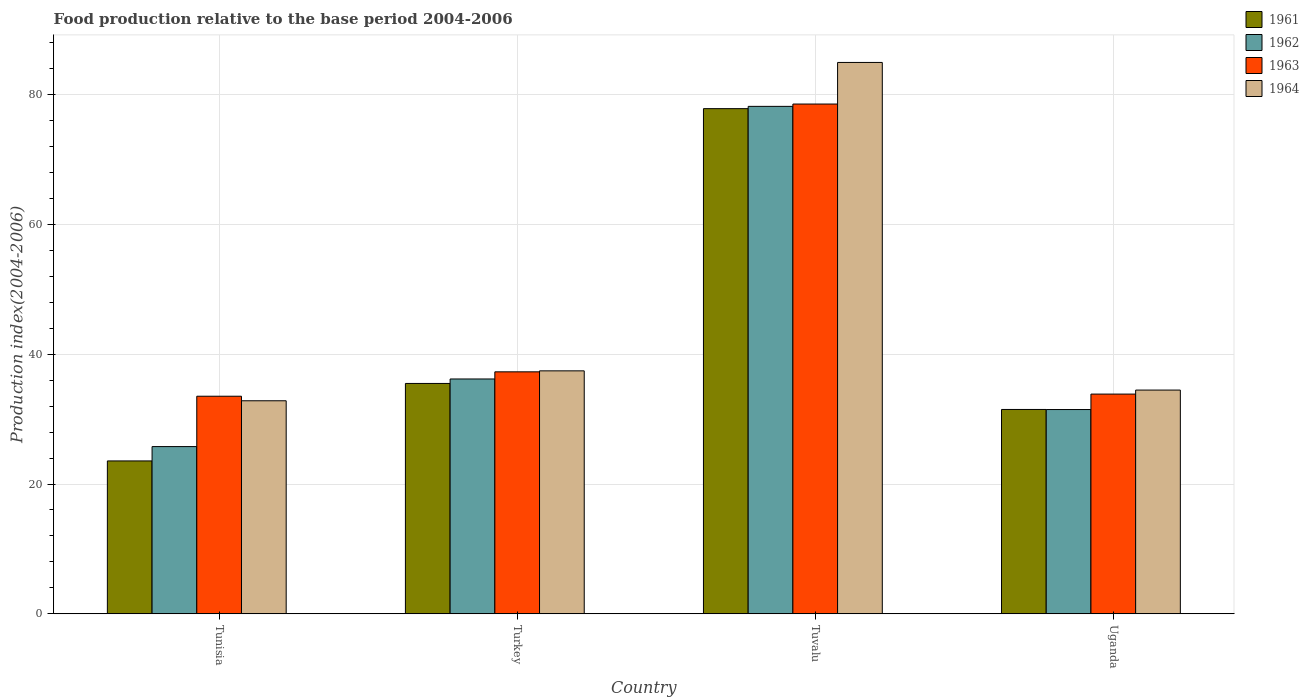How many bars are there on the 3rd tick from the left?
Offer a very short reply. 4. What is the label of the 1st group of bars from the left?
Your answer should be compact. Tunisia. In how many cases, is the number of bars for a given country not equal to the number of legend labels?
Your answer should be very brief. 0. What is the food production index in 1963 in Turkey?
Your response must be concise. 37.29. Across all countries, what is the maximum food production index in 1961?
Provide a short and direct response. 77.85. Across all countries, what is the minimum food production index in 1962?
Your response must be concise. 25.77. In which country was the food production index in 1963 maximum?
Offer a very short reply. Tuvalu. In which country was the food production index in 1964 minimum?
Provide a short and direct response. Tunisia. What is the total food production index in 1964 in the graph?
Your response must be concise. 189.72. What is the difference between the food production index in 1963 in Turkey and that in Uganda?
Offer a terse response. 3.43. What is the difference between the food production index in 1964 in Uganda and the food production index in 1961 in Tunisia?
Your response must be concise. 10.92. What is the average food production index in 1962 per country?
Provide a short and direct response. 42.91. What is the difference between the food production index of/in 1964 and food production index of/in 1962 in Uganda?
Give a very brief answer. 3. What is the ratio of the food production index in 1964 in Turkey to that in Uganda?
Your response must be concise. 1.09. Is the difference between the food production index in 1964 in Tunisia and Tuvalu greater than the difference between the food production index in 1962 in Tunisia and Tuvalu?
Your response must be concise. Yes. What is the difference between the highest and the second highest food production index in 1963?
Your answer should be compact. -3.43. What is the difference between the highest and the lowest food production index in 1963?
Your answer should be compact. 45.03. In how many countries, is the food production index in 1962 greater than the average food production index in 1962 taken over all countries?
Offer a terse response. 1. Is the sum of the food production index in 1962 in Tunisia and Tuvalu greater than the maximum food production index in 1964 across all countries?
Keep it short and to the point. Yes. Is it the case that in every country, the sum of the food production index in 1964 and food production index in 1962 is greater than the sum of food production index in 1961 and food production index in 1963?
Offer a terse response. No. What does the 3rd bar from the left in Tuvalu represents?
Give a very brief answer. 1963. Are the values on the major ticks of Y-axis written in scientific E-notation?
Your response must be concise. No. How many legend labels are there?
Give a very brief answer. 4. What is the title of the graph?
Your response must be concise. Food production relative to the base period 2004-2006. Does "1992" appear as one of the legend labels in the graph?
Provide a succinct answer. No. What is the label or title of the X-axis?
Keep it short and to the point. Country. What is the label or title of the Y-axis?
Give a very brief answer. Production index(2004-2006). What is the Production index(2004-2006) in 1961 in Tunisia?
Your response must be concise. 23.56. What is the Production index(2004-2006) of 1962 in Tunisia?
Your answer should be very brief. 25.77. What is the Production index(2004-2006) in 1963 in Tunisia?
Make the answer very short. 33.53. What is the Production index(2004-2006) in 1964 in Tunisia?
Keep it short and to the point. 32.83. What is the Production index(2004-2006) of 1961 in Turkey?
Give a very brief answer. 35.5. What is the Production index(2004-2006) in 1962 in Turkey?
Offer a very short reply. 36.19. What is the Production index(2004-2006) in 1963 in Turkey?
Your response must be concise. 37.29. What is the Production index(2004-2006) of 1964 in Turkey?
Provide a short and direct response. 37.44. What is the Production index(2004-2006) of 1961 in Tuvalu?
Keep it short and to the point. 77.85. What is the Production index(2004-2006) in 1962 in Tuvalu?
Offer a terse response. 78.2. What is the Production index(2004-2006) of 1963 in Tuvalu?
Your answer should be very brief. 78.56. What is the Production index(2004-2006) in 1964 in Tuvalu?
Make the answer very short. 84.97. What is the Production index(2004-2006) in 1961 in Uganda?
Your answer should be compact. 31.49. What is the Production index(2004-2006) of 1962 in Uganda?
Make the answer very short. 31.48. What is the Production index(2004-2006) of 1963 in Uganda?
Your answer should be compact. 33.86. What is the Production index(2004-2006) of 1964 in Uganda?
Your answer should be very brief. 34.48. Across all countries, what is the maximum Production index(2004-2006) of 1961?
Keep it short and to the point. 77.85. Across all countries, what is the maximum Production index(2004-2006) of 1962?
Provide a short and direct response. 78.2. Across all countries, what is the maximum Production index(2004-2006) in 1963?
Make the answer very short. 78.56. Across all countries, what is the maximum Production index(2004-2006) in 1964?
Keep it short and to the point. 84.97. Across all countries, what is the minimum Production index(2004-2006) in 1961?
Your answer should be compact. 23.56. Across all countries, what is the minimum Production index(2004-2006) in 1962?
Your answer should be compact. 25.77. Across all countries, what is the minimum Production index(2004-2006) of 1963?
Your response must be concise. 33.53. Across all countries, what is the minimum Production index(2004-2006) in 1964?
Your answer should be compact. 32.83. What is the total Production index(2004-2006) of 1961 in the graph?
Give a very brief answer. 168.4. What is the total Production index(2004-2006) of 1962 in the graph?
Offer a very short reply. 171.64. What is the total Production index(2004-2006) in 1963 in the graph?
Provide a short and direct response. 183.24. What is the total Production index(2004-2006) of 1964 in the graph?
Make the answer very short. 189.72. What is the difference between the Production index(2004-2006) in 1961 in Tunisia and that in Turkey?
Provide a short and direct response. -11.94. What is the difference between the Production index(2004-2006) in 1962 in Tunisia and that in Turkey?
Provide a short and direct response. -10.42. What is the difference between the Production index(2004-2006) in 1963 in Tunisia and that in Turkey?
Provide a succinct answer. -3.76. What is the difference between the Production index(2004-2006) in 1964 in Tunisia and that in Turkey?
Provide a short and direct response. -4.61. What is the difference between the Production index(2004-2006) of 1961 in Tunisia and that in Tuvalu?
Provide a succinct answer. -54.29. What is the difference between the Production index(2004-2006) of 1962 in Tunisia and that in Tuvalu?
Provide a succinct answer. -52.43. What is the difference between the Production index(2004-2006) of 1963 in Tunisia and that in Tuvalu?
Provide a short and direct response. -45.03. What is the difference between the Production index(2004-2006) of 1964 in Tunisia and that in Tuvalu?
Make the answer very short. -52.14. What is the difference between the Production index(2004-2006) in 1961 in Tunisia and that in Uganda?
Your answer should be compact. -7.93. What is the difference between the Production index(2004-2006) in 1962 in Tunisia and that in Uganda?
Your answer should be compact. -5.71. What is the difference between the Production index(2004-2006) in 1963 in Tunisia and that in Uganda?
Offer a terse response. -0.33. What is the difference between the Production index(2004-2006) of 1964 in Tunisia and that in Uganda?
Provide a short and direct response. -1.65. What is the difference between the Production index(2004-2006) of 1961 in Turkey and that in Tuvalu?
Your response must be concise. -42.35. What is the difference between the Production index(2004-2006) of 1962 in Turkey and that in Tuvalu?
Offer a very short reply. -42.01. What is the difference between the Production index(2004-2006) in 1963 in Turkey and that in Tuvalu?
Ensure brevity in your answer.  -41.27. What is the difference between the Production index(2004-2006) of 1964 in Turkey and that in Tuvalu?
Keep it short and to the point. -47.53. What is the difference between the Production index(2004-2006) in 1961 in Turkey and that in Uganda?
Ensure brevity in your answer.  4.01. What is the difference between the Production index(2004-2006) in 1962 in Turkey and that in Uganda?
Offer a terse response. 4.71. What is the difference between the Production index(2004-2006) of 1963 in Turkey and that in Uganda?
Provide a short and direct response. 3.43. What is the difference between the Production index(2004-2006) of 1964 in Turkey and that in Uganda?
Provide a succinct answer. 2.96. What is the difference between the Production index(2004-2006) in 1961 in Tuvalu and that in Uganda?
Your response must be concise. 46.36. What is the difference between the Production index(2004-2006) in 1962 in Tuvalu and that in Uganda?
Your answer should be compact. 46.72. What is the difference between the Production index(2004-2006) of 1963 in Tuvalu and that in Uganda?
Provide a short and direct response. 44.7. What is the difference between the Production index(2004-2006) in 1964 in Tuvalu and that in Uganda?
Make the answer very short. 50.49. What is the difference between the Production index(2004-2006) in 1961 in Tunisia and the Production index(2004-2006) in 1962 in Turkey?
Give a very brief answer. -12.63. What is the difference between the Production index(2004-2006) in 1961 in Tunisia and the Production index(2004-2006) in 1963 in Turkey?
Keep it short and to the point. -13.73. What is the difference between the Production index(2004-2006) of 1961 in Tunisia and the Production index(2004-2006) of 1964 in Turkey?
Your answer should be compact. -13.88. What is the difference between the Production index(2004-2006) in 1962 in Tunisia and the Production index(2004-2006) in 1963 in Turkey?
Your response must be concise. -11.52. What is the difference between the Production index(2004-2006) in 1962 in Tunisia and the Production index(2004-2006) in 1964 in Turkey?
Your answer should be compact. -11.67. What is the difference between the Production index(2004-2006) in 1963 in Tunisia and the Production index(2004-2006) in 1964 in Turkey?
Your answer should be compact. -3.91. What is the difference between the Production index(2004-2006) in 1961 in Tunisia and the Production index(2004-2006) in 1962 in Tuvalu?
Provide a short and direct response. -54.64. What is the difference between the Production index(2004-2006) in 1961 in Tunisia and the Production index(2004-2006) in 1963 in Tuvalu?
Your answer should be compact. -55. What is the difference between the Production index(2004-2006) in 1961 in Tunisia and the Production index(2004-2006) in 1964 in Tuvalu?
Make the answer very short. -61.41. What is the difference between the Production index(2004-2006) of 1962 in Tunisia and the Production index(2004-2006) of 1963 in Tuvalu?
Provide a short and direct response. -52.79. What is the difference between the Production index(2004-2006) of 1962 in Tunisia and the Production index(2004-2006) of 1964 in Tuvalu?
Ensure brevity in your answer.  -59.2. What is the difference between the Production index(2004-2006) of 1963 in Tunisia and the Production index(2004-2006) of 1964 in Tuvalu?
Your answer should be very brief. -51.44. What is the difference between the Production index(2004-2006) in 1961 in Tunisia and the Production index(2004-2006) in 1962 in Uganda?
Provide a short and direct response. -7.92. What is the difference between the Production index(2004-2006) of 1961 in Tunisia and the Production index(2004-2006) of 1964 in Uganda?
Provide a short and direct response. -10.92. What is the difference between the Production index(2004-2006) in 1962 in Tunisia and the Production index(2004-2006) in 1963 in Uganda?
Offer a terse response. -8.09. What is the difference between the Production index(2004-2006) in 1962 in Tunisia and the Production index(2004-2006) in 1964 in Uganda?
Give a very brief answer. -8.71. What is the difference between the Production index(2004-2006) in 1963 in Tunisia and the Production index(2004-2006) in 1964 in Uganda?
Your response must be concise. -0.95. What is the difference between the Production index(2004-2006) of 1961 in Turkey and the Production index(2004-2006) of 1962 in Tuvalu?
Your answer should be very brief. -42.7. What is the difference between the Production index(2004-2006) in 1961 in Turkey and the Production index(2004-2006) in 1963 in Tuvalu?
Provide a succinct answer. -43.06. What is the difference between the Production index(2004-2006) in 1961 in Turkey and the Production index(2004-2006) in 1964 in Tuvalu?
Offer a very short reply. -49.47. What is the difference between the Production index(2004-2006) in 1962 in Turkey and the Production index(2004-2006) in 1963 in Tuvalu?
Your answer should be very brief. -42.37. What is the difference between the Production index(2004-2006) in 1962 in Turkey and the Production index(2004-2006) in 1964 in Tuvalu?
Offer a very short reply. -48.78. What is the difference between the Production index(2004-2006) in 1963 in Turkey and the Production index(2004-2006) in 1964 in Tuvalu?
Your answer should be very brief. -47.68. What is the difference between the Production index(2004-2006) of 1961 in Turkey and the Production index(2004-2006) of 1962 in Uganda?
Offer a terse response. 4.02. What is the difference between the Production index(2004-2006) of 1961 in Turkey and the Production index(2004-2006) of 1963 in Uganda?
Your response must be concise. 1.64. What is the difference between the Production index(2004-2006) of 1961 in Turkey and the Production index(2004-2006) of 1964 in Uganda?
Provide a short and direct response. 1.02. What is the difference between the Production index(2004-2006) of 1962 in Turkey and the Production index(2004-2006) of 1963 in Uganda?
Provide a short and direct response. 2.33. What is the difference between the Production index(2004-2006) of 1962 in Turkey and the Production index(2004-2006) of 1964 in Uganda?
Make the answer very short. 1.71. What is the difference between the Production index(2004-2006) in 1963 in Turkey and the Production index(2004-2006) in 1964 in Uganda?
Provide a succinct answer. 2.81. What is the difference between the Production index(2004-2006) of 1961 in Tuvalu and the Production index(2004-2006) of 1962 in Uganda?
Give a very brief answer. 46.37. What is the difference between the Production index(2004-2006) of 1961 in Tuvalu and the Production index(2004-2006) of 1963 in Uganda?
Your answer should be very brief. 43.99. What is the difference between the Production index(2004-2006) of 1961 in Tuvalu and the Production index(2004-2006) of 1964 in Uganda?
Your response must be concise. 43.37. What is the difference between the Production index(2004-2006) of 1962 in Tuvalu and the Production index(2004-2006) of 1963 in Uganda?
Your response must be concise. 44.34. What is the difference between the Production index(2004-2006) in 1962 in Tuvalu and the Production index(2004-2006) in 1964 in Uganda?
Your response must be concise. 43.72. What is the difference between the Production index(2004-2006) of 1963 in Tuvalu and the Production index(2004-2006) of 1964 in Uganda?
Your response must be concise. 44.08. What is the average Production index(2004-2006) in 1961 per country?
Offer a very short reply. 42.1. What is the average Production index(2004-2006) of 1962 per country?
Your answer should be compact. 42.91. What is the average Production index(2004-2006) in 1963 per country?
Your answer should be very brief. 45.81. What is the average Production index(2004-2006) in 1964 per country?
Give a very brief answer. 47.43. What is the difference between the Production index(2004-2006) of 1961 and Production index(2004-2006) of 1962 in Tunisia?
Provide a short and direct response. -2.21. What is the difference between the Production index(2004-2006) in 1961 and Production index(2004-2006) in 1963 in Tunisia?
Ensure brevity in your answer.  -9.97. What is the difference between the Production index(2004-2006) in 1961 and Production index(2004-2006) in 1964 in Tunisia?
Keep it short and to the point. -9.27. What is the difference between the Production index(2004-2006) of 1962 and Production index(2004-2006) of 1963 in Tunisia?
Provide a succinct answer. -7.76. What is the difference between the Production index(2004-2006) in 1962 and Production index(2004-2006) in 1964 in Tunisia?
Your answer should be very brief. -7.06. What is the difference between the Production index(2004-2006) in 1963 and Production index(2004-2006) in 1964 in Tunisia?
Offer a very short reply. 0.7. What is the difference between the Production index(2004-2006) of 1961 and Production index(2004-2006) of 1962 in Turkey?
Make the answer very short. -0.69. What is the difference between the Production index(2004-2006) of 1961 and Production index(2004-2006) of 1963 in Turkey?
Ensure brevity in your answer.  -1.79. What is the difference between the Production index(2004-2006) in 1961 and Production index(2004-2006) in 1964 in Turkey?
Offer a terse response. -1.94. What is the difference between the Production index(2004-2006) in 1962 and Production index(2004-2006) in 1963 in Turkey?
Your answer should be very brief. -1.1. What is the difference between the Production index(2004-2006) in 1962 and Production index(2004-2006) in 1964 in Turkey?
Offer a terse response. -1.25. What is the difference between the Production index(2004-2006) of 1961 and Production index(2004-2006) of 1962 in Tuvalu?
Make the answer very short. -0.35. What is the difference between the Production index(2004-2006) of 1961 and Production index(2004-2006) of 1963 in Tuvalu?
Your answer should be very brief. -0.71. What is the difference between the Production index(2004-2006) in 1961 and Production index(2004-2006) in 1964 in Tuvalu?
Offer a terse response. -7.12. What is the difference between the Production index(2004-2006) in 1962 and Production index(2004-2006) in 1963 in Tuvalu?
Your answer should be very brief. -0.36. What is the difference between the Production index(2004-2006) of 1962 and Production index(2004-2006) of 1964 in Tuvalu?
Keep it short and to the point. -6.77. What is the difference between the Production index(2004-2006) of 1963 and Production index(2004-2006) of 1964 in Tuvalu?
Give a very brief answer. -6.41. What is the difference between the Production index(2004-2006) of 1961 and Production index(2004-2006) of 1962 in Uganda?
Keep it short and to the point. 0.01. What is the difference between the Production index(2004-2006) of 1961 and Production index(2004-2006) of 1963 in Uganda?
Keep it short and to the point. -2.37. What is the difference between the Production index(2004-2006) in 1961 and Production index(2004-2006) in 1964 in Uganda?
Keep it short and to the point. -2.99. What is the difference between the Production index(2004-2006) of 1962 and Production index(2004-2006) of 1963 in Uganda?
Provide a short and direct response. -2.38. What is the difference between the Production index(2004-2006) of 1962 and Production index(2004-2006) of 1964 in Uganda?
Keep it short and to the point. -3. What is the difference between the Production index(2004-2006) in 1963 and Production index(2004-2006) in 1964 in Uganda?
Your answer should be very brief. -0.62. What is the ratio of the Production index(2004-2006) of 1961 in Tunisia to that in Turkey?
Your answer should be very brief. 0.66. What is the ratio of the Production index(2004-2006) of 1962 in Tunisia to that in Turkey?
Offer a very short reply. 0.71. What is the ratio of the Production index(2004-2006) of 1963 in Tunisia to that in Turkey?
Your answer should be very brief. 0.9. What is the ratio of the Production index(2004-2006) in 1964 in Tunisia to that in Turkey?
Give a very brief answer. 0.88. What is the ratio of the Production index(2004-2006) in 1961 in Tunisia to that in Tuvalu?
Provide a short and direct response. 0.3. What is the ratio of the Production index(2004-2006) of 1962 in Tunisia to that in Tuvalu?
Your answer should be compact. 0.33. What is the ratio of the Production index(2004-2006) in 1963 in Tunisia to that in Tuvalu?
Your response must be concise. 0.43. What is the ratio of the Production index(2004-2006) of 1964 in Tunisia to that in Tuvalu?
Keep it short and to the point. 0.39. What is the ratio of the Production index(2004-2006) of 1961 in Tunisia to that in Uganda?
Ensure brevity in your answer.  0.75. What is the ratio of the Production index(2004-2006) in 1962 in Tunisia to that in Uganda?
Provide a short and direct response. 0.82. What is the ratio of the Production index(2004-2006) in 1963 in Tunisia to that in Uganda?
Offer a very short reply. 0.99. What is the ratio of the Production index(2004-2006) in 1964 in Tunisia to that in Uganda?
Provide a short and direct response. 0.95. What is the ratio of the Production index(2004-2006) in 1961 in Turkey to that in Tuvalu?
Provide a succinct answer. 0.46. What is the ratio of the Production index(2004-2006) of 1962 in Turkey to that in Tuvalu?
Offer a terse response. 0.46. What is the ratio of the Production index(2004-2006) in 1963 in Turkey to that in Tuvalu?
Your response must be concise. 0.47. What is the ratio of the Production index(2004-2006) of 1964 in Turkey to that in Tuvalu?
Provide a short and direct response. 0.44. What is the ratio of the Production index(2004-2006) in 1961 in Turkey to that in Uganda?
Your answer should be very brief. 1.13. What is the ratio of the Production index(2004-2006) of 1962 in Turkey to that in Uganda?
Offer a very short reply. 1.15. What is the ratio of the Production index(2004-2006) of 1963 in Turkey to that in Uganda?
Your answer should be compact. 1.1. What is the ratio of the Production index(2004-2006) in 1964 in Turkey to that in Uganda?
Give a very brief answer. 1.09. What is the ratio of the Production index(2004-2006) of 1961 in Tuvalu to that in Uganda?
Provide a succinct answer. 2.47. What is the ratio of the Production index(2004-2006) of 1962 in Tuvalu to that in Uganda?
Your response must be concise. 2.48. What is the ratio of the Production index(2004-2006) of 1963 in Tuvalu to that in Uganda?
Make the answer very short. 2.32. What is the ratio of the Production index(2004-2006) in 1964 in Tuvalu to that in Uganda?
Keep it short and to the point. 2.46. What is the difference between the highest and the second highest Production index(2004-2006) in 1961?
Keep it short and to the point. 42.35. What is the difference between the highest and the second highest Production index(2004-2006) in 1962?
Your response must be concise. 42.01. What is the difference between the highest and the second highest Production index(2004-2006) of 1963?
Offer a very short reply. 41.27. What is the difference between the highest and the second highest Production index(2004-2006) of 1964?
Provide a short and direct response. 47.53. What is the difference between the highest and the lowest Production index(2004-2006) in 1961?
Provide a succinct answer. 54.29. What is the difference between the highest and the lowest Production index(2004-2006) in 1962?
Your response must be concise. 52.43. What is the difference between the highest and the lowest Production index(2004-2006) in 1963?
Your answer should be compact. 45.03. What is the difference between the highest and the lowest Production index(2004-2006) in 1964?
Provide a succinct answer. 52.14. 